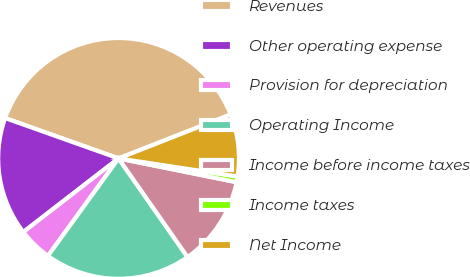Convert chart to OTSL. <chart><loc_0><loc_0><loc_500><loc_500><pie_chart><fcel>Revenues<fcel>Other operating expense<fcel>Provision for depreciation<fcel>Operating Income<fcel>Income before income taxes<fcel>Income taxes<fcel>Net Income<nl><fcel>38.62%<fcel>15.91%<fcel>4.55%<fcel>19.69%<fcel>12.12%<fcel>0.77%<fcel>8.34%<nl></chart> 